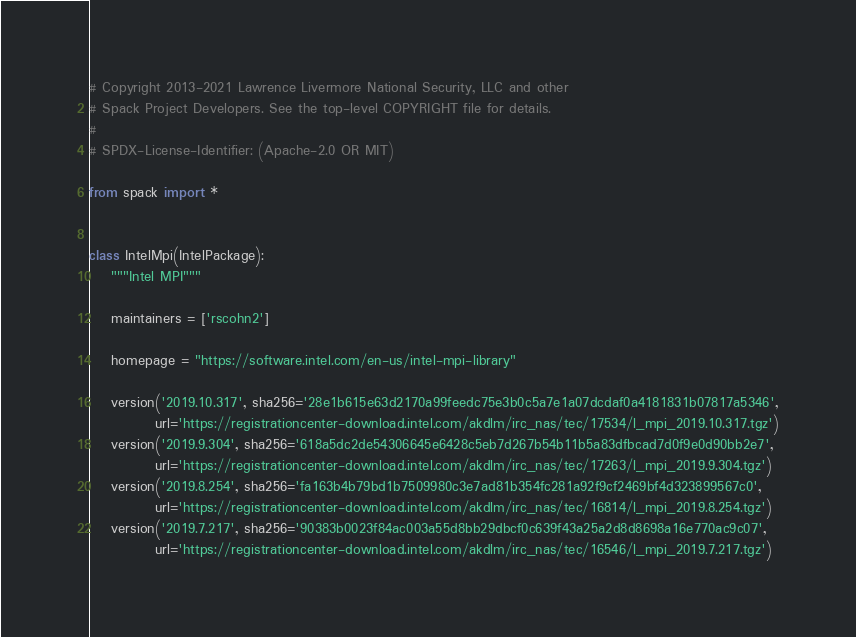Convert code to text. <code><loc_0><loc_0><loc_500><loc_500><_Python_># Copyright 2013-2021 Lawrence Livermore National Security, LLC and other
# Spack Project Developers. See the top-level COPYRIGHT file for details.
#
# SPDX-License-Identifier: (Apache-2.0 OR MIT)

from spack import *


class IntelMpi(IntelPackage):
    """Intel MPI"""

    maintainers = ['rscohn2']

    homepage = "https://software.intel.com/en-us/intel-mpi-library"

    version('2019.10.317', sha256='28e1b615e63d2170a99feedc75e3b0c5a7e1a07dcdaf0a4181831b07817a5346',
            url='https://registrationcenter-download.intel.com/akdlm/irc_nas/tec/17534/l_mpi_2019.10.317.tgz')
    version('2019.9.304', sha256='618a5dc2de54306645e6428c5eb7d267b54b11b5a83dfbcad7d0f9e0d90bb2e7',
            url='https://registrationcenter-download.intel.com/akdlm/irc_nas/tec/17263/l_mpi_2019.9.304.tgz')
    version('2019.8.254', sha256='fa163b4b79bd1b7509980c3e7ad81b354fc281a92f9cf2469bf4d323899567c0',
            url='https://registrationcenter-download.intel.com/akdlm/irc_nas/tec/16814/l_mpi_2019.8.254.tgz')
    version('2019.7.217', sha256='90383b0023f84ac003a55d8bb29dbcf0c639f43a25a2d8d8698a16e770ac9c07',
            url='https://registrationcenter-download.intel.com/akdlm/irc_nas/tec/16546/l_mpi_2019.7.217.tgz')</code> 